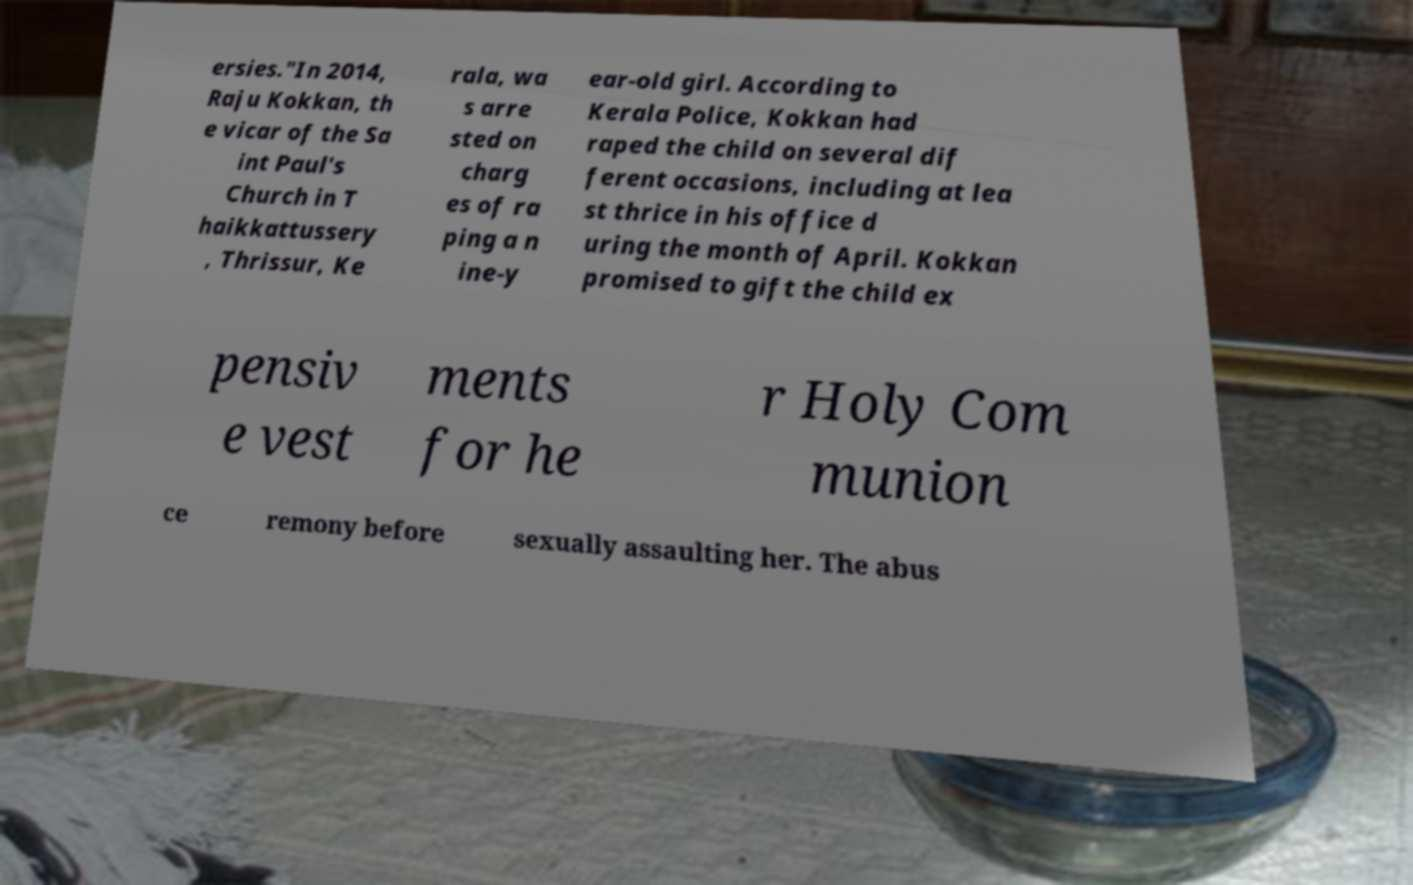Please read and relay the text visible in this image. What does it say? ersies."In 2014, Raju Kokkan, th e vicar of the Sa int Paul's Church in T haikkattussery , Thrissur, Ke rala, wa s arre sted on charg es of ra ping a n ine-y ear-old girl. According to Kerala Police, Kokkan had raped the child on several dif ferent occasions, including at lea st thrice in his office d uring the month of April. Kokkan promised to gift the child ex pensiv e vest ments for he r Holy Com munion ce remony before sexually assaulting her. The abus 